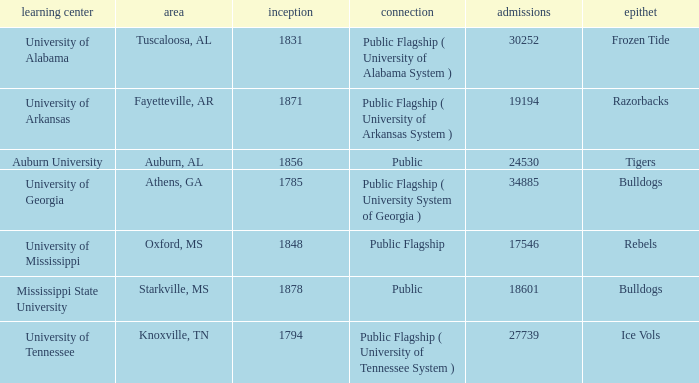What is the maximum enrollment of the schools? 34885.0. 